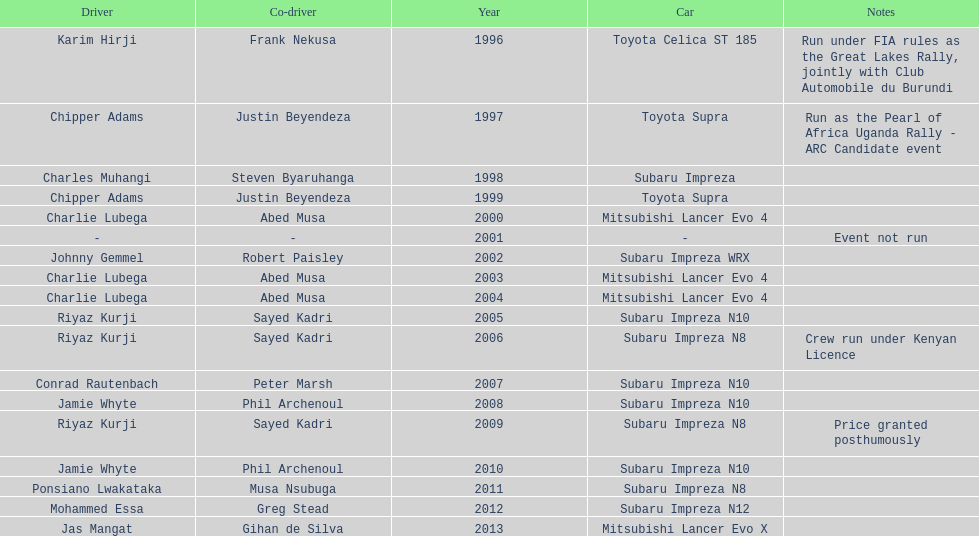How many drivers are racing with a co-driver from a different country? 1. 